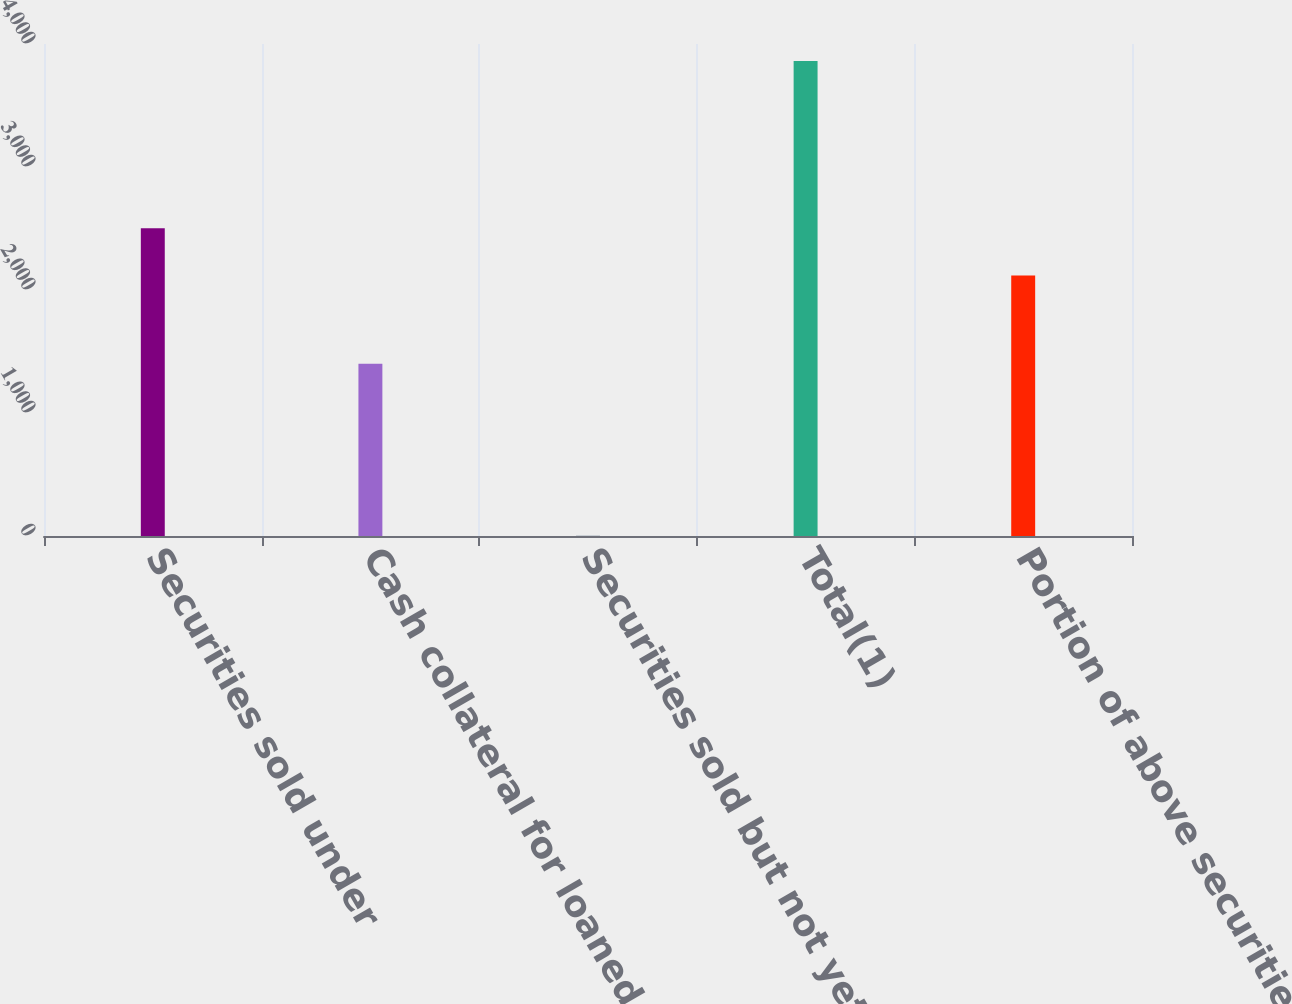Convert chart. <chart><loc_0><loc_0><loc_500><loc_500><bar_chart><fcel>Securities sold under<fcel>Cash collateral for loaned<fcel>Securities sold but not yet<fcel>Total(1)<fcel>Portion of above securities<nl><fcel>2502.96<fcel>1401<fcel>2.38<fcel>3862<fcel>2117<nl></chart> 